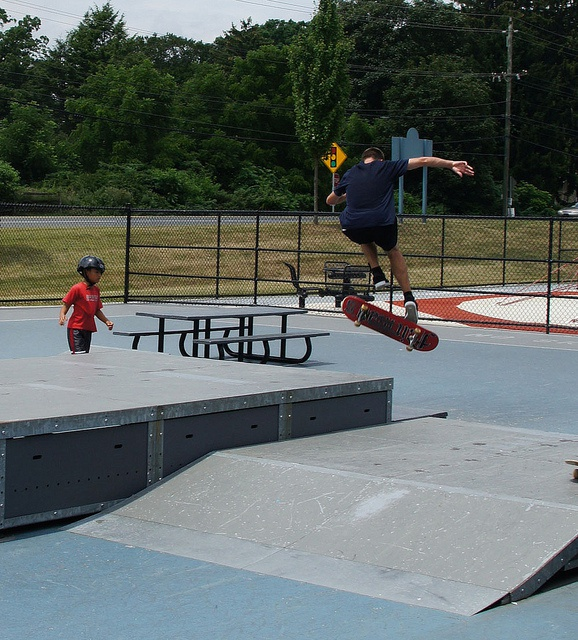Describe the objects in this image and their specific colors. I can see people in lightgray, black, maroon, gray, and navy tones, people in lightgray, maroon, black, brown, and gray tones, skateboard in lightgray, black, maroon, gray, and brown tones, dining table in lightgray, darkgray, black, and gray tones, and bench in lightgray, darkgray, black, and gray tones in this image. 